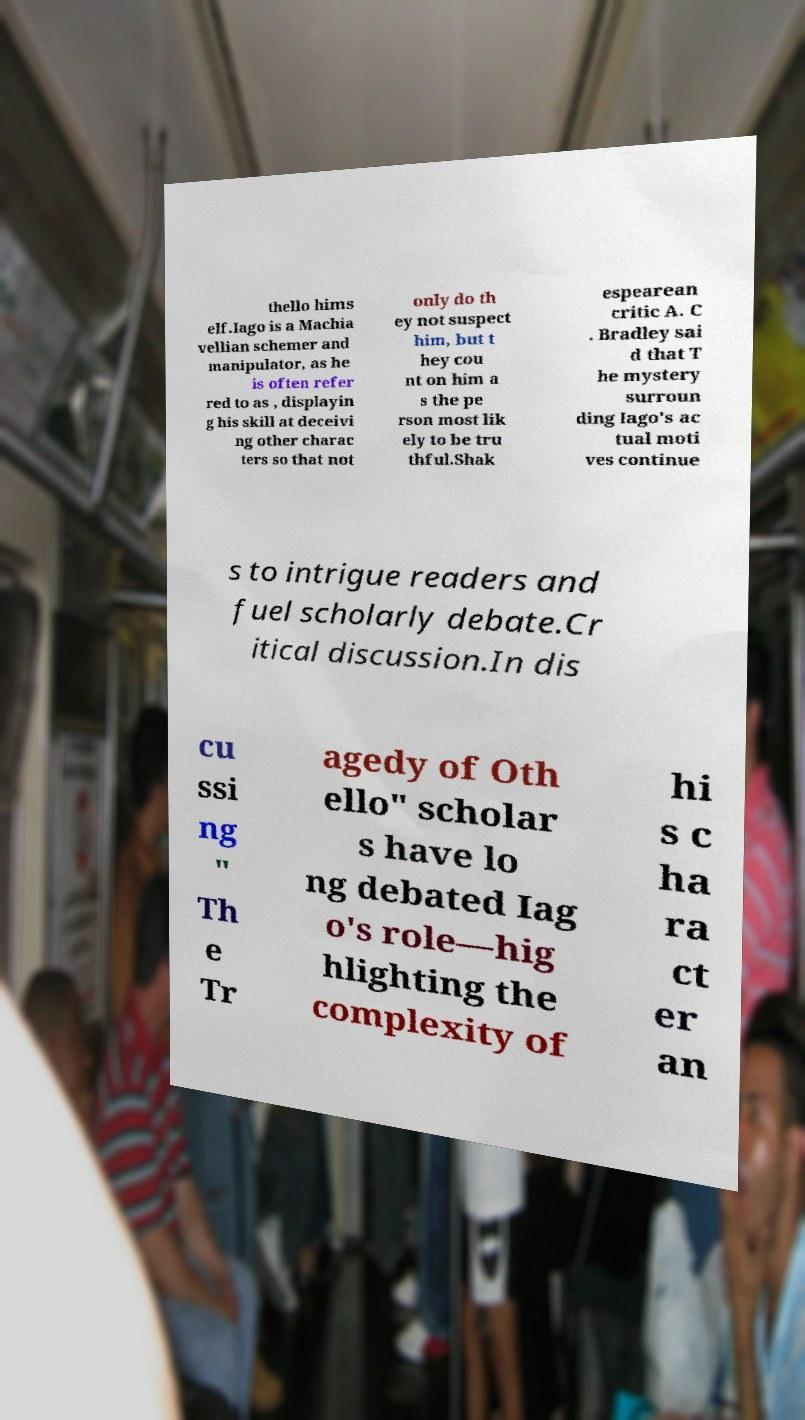Can you accurately transcribe the text from the provided image for me? thello hims elf.Iago is a Machia vellian schemer and manipulator, as he is often refer red to as , displayin g his skill at deceivi ng other charac ters so that not only do th ey not suspect him, but t hey cou nt on him a s the pe rson most lik ely to be tru thful.Shak espearean critic A. C . Bradley sai d that T he mystery surroun ding Iago's ac tual moti ves continue s to intrigue readers and fuel scholarly debate.Cr itical discussion.In dis cu ssi ng " Th e Tr agedy of Oth ello" scholar s have lo ng debated Iag o's role—hig hlighting the complexity of hi s c ha ra ct er an 